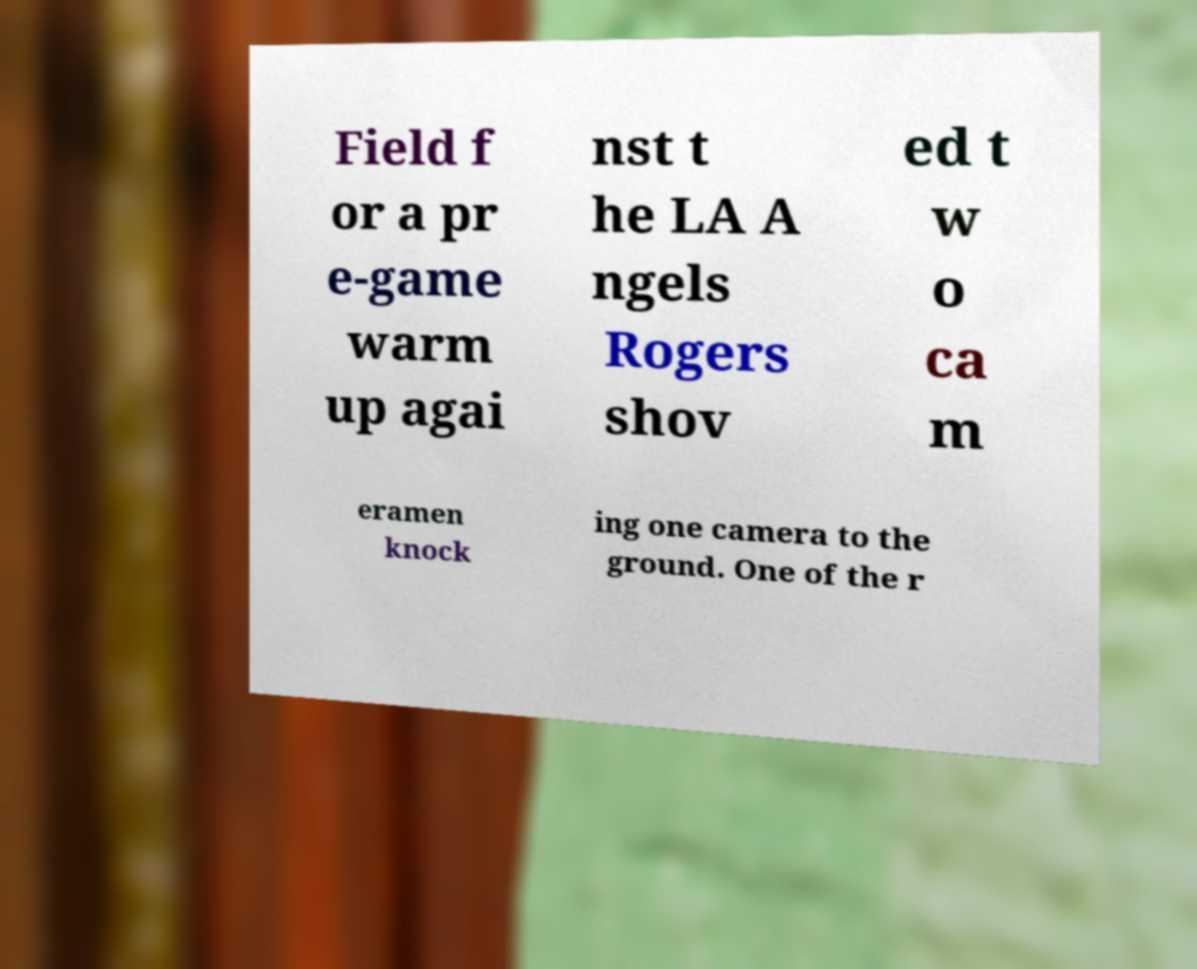Can you read and provide the text displayed in the image?This photo seems to have some interesting text. Can you extract and type it out for me? Field f or a pr e-game warm up agai nst t he LA A ngels Rogers shov ed t w o ca m eramen knock ing one camera to the ground. One of the r 